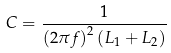Convert formula to latex. <formula><loc_0><loc_0><loc_500><loc_500>C = { \frac { 1 } { \left ( 2 \pi f \right ) ^ { 2 } \left ( L _ { 1 } + L _ { 2 } \right ) } }</formula> 